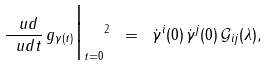<formula> <loc_0><loc_0><loc_500><loc_500>\| \frac { \ u d } { \ u d t } \, g _ { \gamma ( t ) } \Big | _ { t = 0 } \| ^ { 2 } \ = \ \dot { \gamma } ^ { i } ( 0 ) \, \dot { \gamma } ^ { j } ( 0 ) \, \mathcal { G } _ { i j } ( \lambda ) ,</formula> 